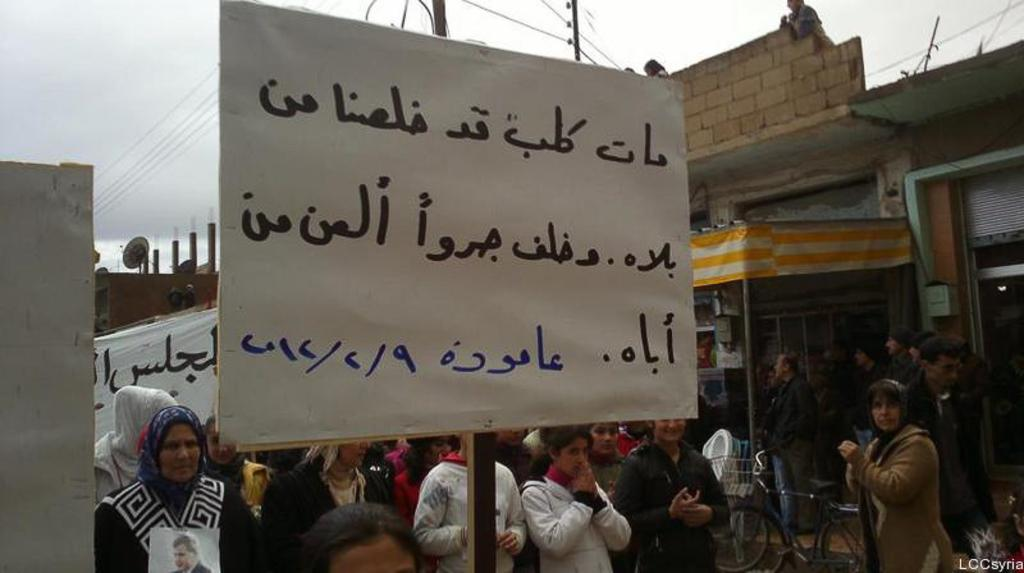Who or what can be seen in the image? There are people in the image. What is the board with writing used for in the image? The board with writing is likely used for communication or displaying information. What type of structures are present in the image? There are houses and buildings in the image. What type of quill is being used by the people in the image? There is no quill visible in the image, as it is a modern scene with people and structures. How does the knife play a role in the image? There is no knife present in the image, so it does not play a role. 